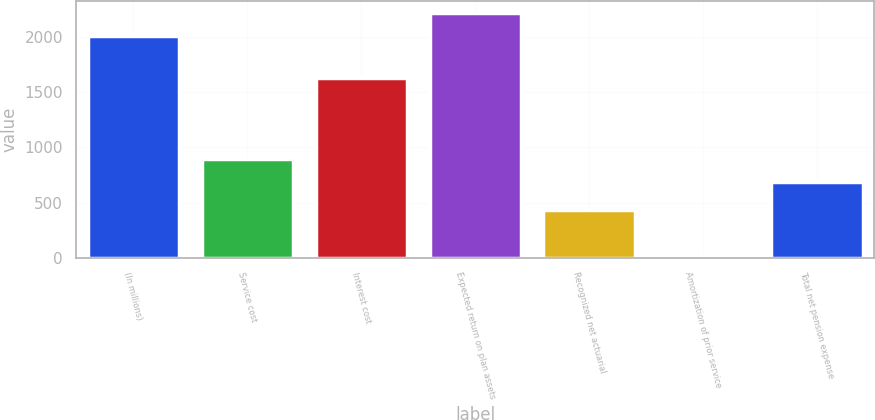Convert chart to OTSL. <chart><loc_0><loc_0><loc_500><loc_500><bar_chart><fcel>(In millions)<fcel>Service cost<fcel>Interest cost<fcel>Expected return on plan assets<fcel>Recognized net actuarial<fcel>Amortization of prior service<fcel>Total net pension expense<nl><fcel>2007<fcel>890.9<fcel>1631<fcel>2210.9<fcel>431.8<fcel>24<fcel>687<nl></chart> 